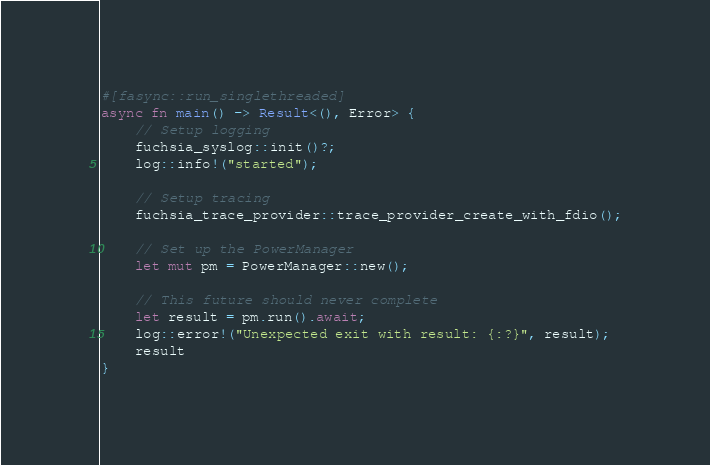Convert code to text. <code><loc_0><loc_0><loc_500><loc_500><_Rust_>
#[fasync::run_singlethreaded]
async fn main() -> Result<(), Error> {
    // Setup logging
    fuchsia_syslog::init()?;
    log::info!("started");

    // Setup tracing
    fuchsia_trace_provider::trace_provider_create_with_fdio();

    // Set up the PowerManager
    let mut pm = PowerManager::new();

    // This future should never complete
    let result = pm.run().await;
    log::error!("Unexpected exit with result: {:?}", result);
    result
}
</code> 